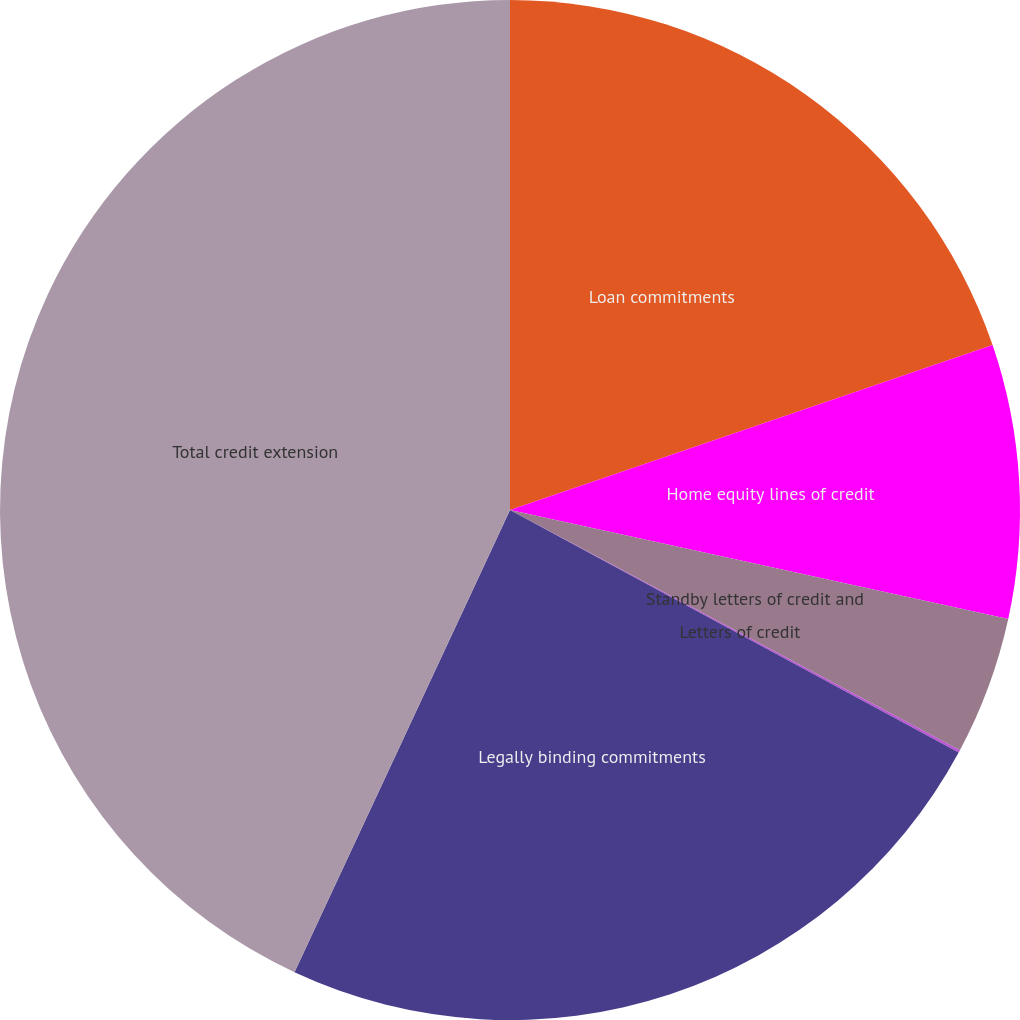Convert chart to OTSL. <chart><loc_0><loc_0><loc_500><loc_500><pie_chart><fcel>Loan commitments<fcel>Home equity lines of credit<fcel>Standby letters of credit and<fcel>Letters of credit<fcel>Legally binding commitments<fcel>Total credit extension<nl><fcel>19.76%<fcel>8.67%<fcel>4.38%<fcel>0.08%<fcel>24.06%<fcel>43.06%<nl></chart> 